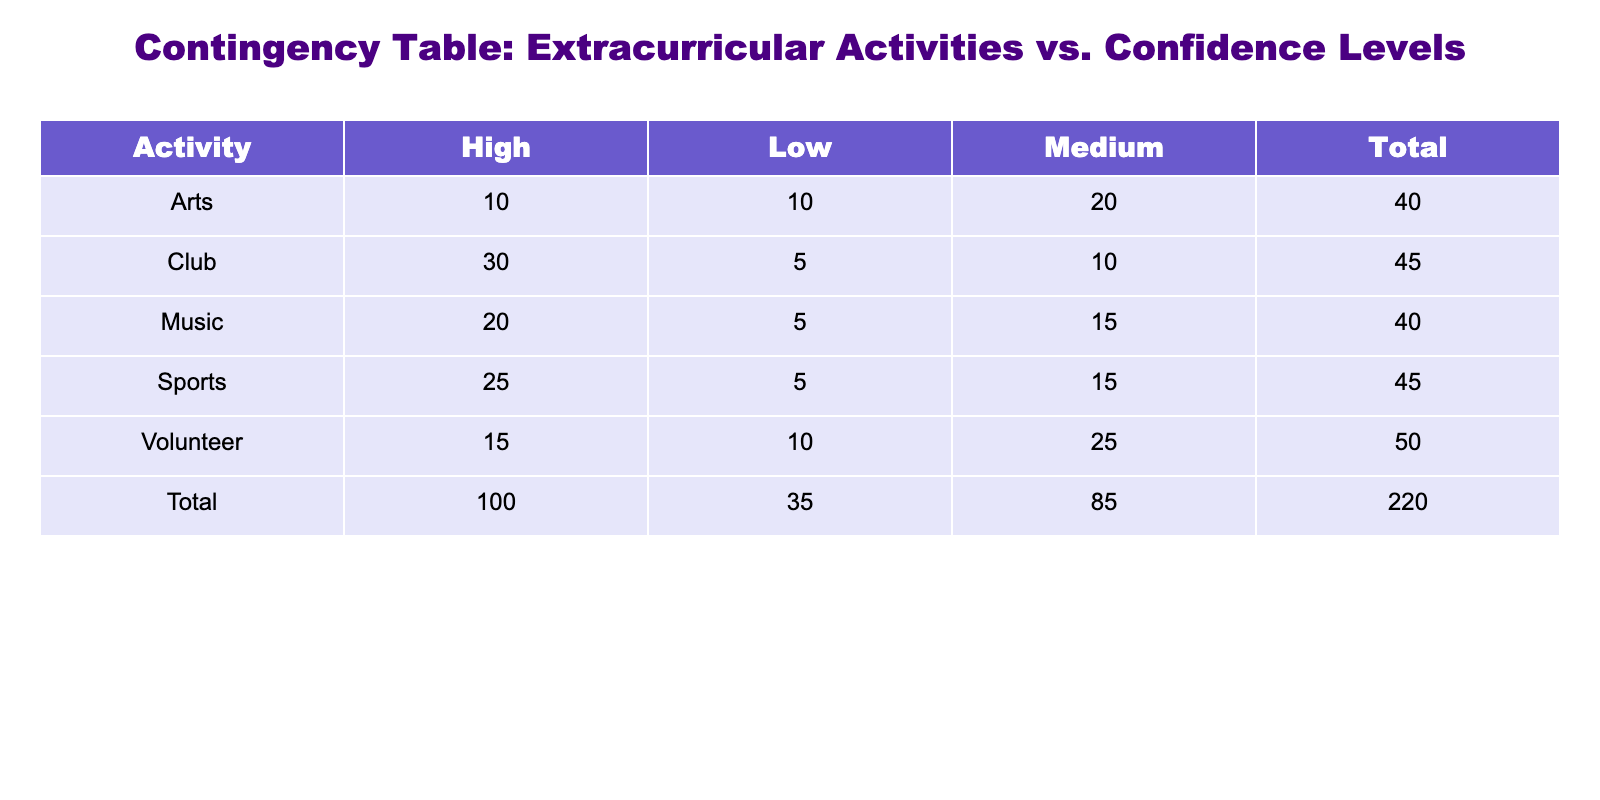What is the total number of students who participated in Sports? The table shows that there are 25 students with high confidence, 15 with medium confidence, and 5 with low confidence in Sports. Adding these counts gives us 25 + 15 + 5 = 45.
Answer: 45 Which extracurricular activity has the highest total participation? To find this, we must look at the total participation for each activity. For Club, the total is 30 + 10 + 5 = 45. For Sports, it's 45, for Arts it's 40, for Music it's 40, and for Volunteer it's 50. The highest total is 50 for Volunteer.
Answer: Volunteer Is there a higher count of students with high confidence in Clubs or in Sports? The count of high confidence students in Clubs is 30, while in Sports it is 25. Since 30 is greater than 25, there are more high confidence students in Clubs.
Answer: Yes What percentage of students participating in Arts have medium confidence? The total number of students participating in Arts is 10 + 20 + 10 = 40. The number of students with medium confidence is 20. The percentage is calculated by (20/40) * 100 = 50%.
Answer: 50% How many more students have low confidence in Volunteer compared to Arts? In Volunteer, there are 10 students with low confidence, while in Arts, there are 10 as well. Subtracting these counts gives 10 - 10 = 0.
Answer: 0 What is the total count of students with high confidence across all activities? The high confidence counts are 25 (Sports) + 10 (Arts) + 20 (Music) + 30 (Club) + 15 (Volunteer). Adding these gives 25 + 10 + 20 + 30 + 15 = 110.
Answer: 110 Are there more students with medium confidence in Music than in Arts? The count of medium confidence students in Music is 15, while in Arts, it is 20. Since 15 is less than 20, there are not more students in Music.
Answer: No What is the difference in total participation between the activity with the lowest and highest total? The lowest total participation is 40 (for Arts or Music), and the highest is 50 (for Volunteer). The difference is 50 - 40 = 10.
Answer: 10 